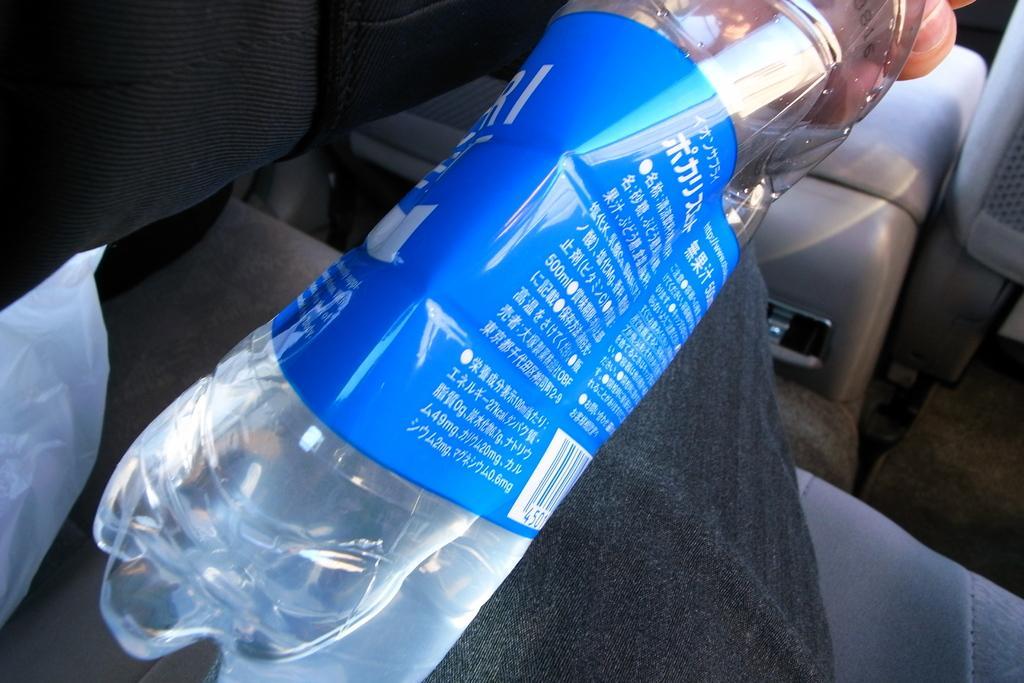How would you summarize this image in a sentence or two? There is a person holding a bottle. There is a cover and this is seat. 